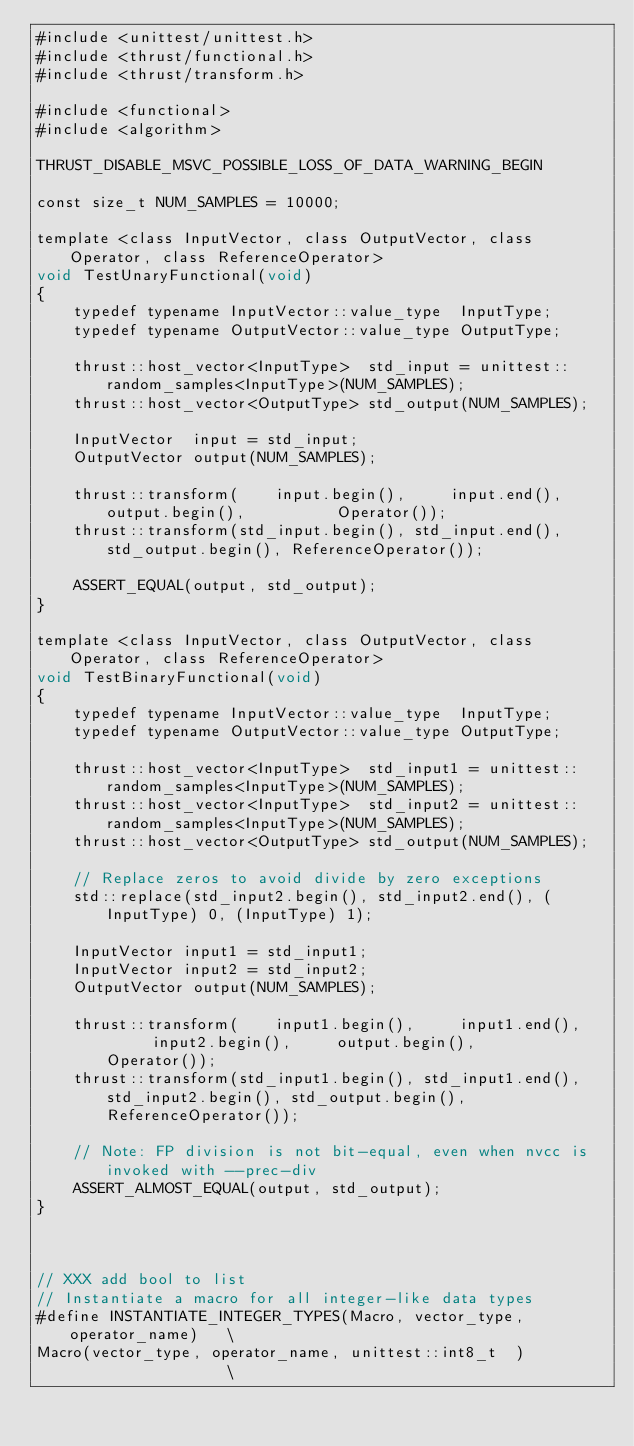Convert code to text. <code><loc_0><loc_0><loc_500><loc_500><_Cuda_>#include <unittest/unittest.h>
#include <thrust/functional.h>
#include <thrust/transform.h>

#include <functional>
#include <algorithm>

THRUST_DISABLE_MSVC_POSSIBLE_LOSS_OF_DATA_WARNING_BEGIN
    
const size_t NUM_SAMPLES = 10000;

template <class InputVector, class OutputVector, class Operator, class ReferenceOperator>
void TestUnaryFunctional(void)
{
    typedef typename InputVector::value_type  InputType;
    typedef typename OutputVector::value_type OutputType;
    
    thrust::host_vector<InputType>  std_input = unittest::random_samples<InputType>(NUM_SAMPLES);
    thrust::host_vector<OutputType> std_output(NUM_SAMPLES);

    InputVector  input = std_input;
    OutputVector output(NUM_SAMPLES);

    thrust::transform(    input.begin(),     input.end(),     output.begin(),          Operator());
    thrust::transform(std_input.begin(), std_input.end(), std_output.begin(), ReferenceOperator());

    ASSERT_EQUAL(output, std_output);
}

template <class InputVector, class OutputVector, class Operator, class ReferenceOperator>
void TestBinaryFunctional(void)
{
    typedef typename InputVector::value_type  InputType;
    typedef typename OutputVector::value_type OutputType;
    
    thrust::host_vector<InputType>  std_input1 = unittest::random_samples<InputType>(NUM_SAMPLES);
    thrust::host_vector<InputType>  std_input2 = unittest::random_samples<InputType>(NUM_SAMPLES);
    thrust::host_vector<OutputType> std_output(NUM_SAMPLES);

    // Replace zeros to avoid divide by zero exceptions
    std::replace(std_input2.begin(), std_input2.end(), (InputType) 0, (InputType) 1);

    InputVector input1 = std_input1; 
    InputVector input2 = std_input2; 
    OutputVector output(NUM_SAMPLES);

    thrust::transform(    input1.begin(),     input1.end(),      input2.begin(),     output.begin(),          Operator());
    thrust::transform(std_input1.begin(), std_input1.end(),  std_input2.begin(), std_output.begin(), ReferenceOperator());

    // Note: FP division is not bit-equal, even when nvcc is invoked with --prec-div
    ASSERT_ALMOST_EQUAL(output, std_output);
}



// XXX add bool to list
// Instantiate a macro for all integer-like data types
#define INSTANTIATE_INTEGER_TYPES(Macro, vector_type, operator_name)   \
Macro(vector_type, operator_name, unittest::int8_t  )                  \</code> 